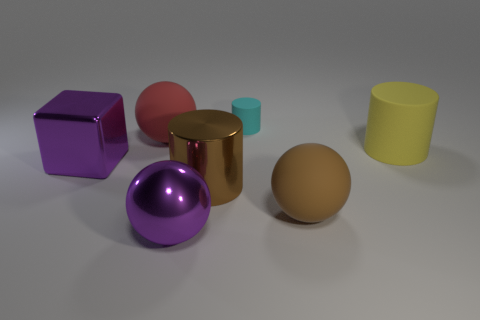Add 3 big yellow matte objects. How many objects exist? 10 Subtract all big shiny cylinders. How many cylinders are left? 2 Subtract 1 cylinders. How many cylinders are left? 2 Subtract all balls. How many objects are left? 4 Add 1 brown matte things. How many brown matte things are left? 2 Add 2 yellow things. How many yellow things exist? 3 Subtract 0 cyan cubes. How many objects are left? 7 Subtract all blue balls. Subtract all cyan cylinders. How many balls are left? 3 Subtract all tiny purple metallic cylinders. Subtract all big brown cylinders. How many objects are left? 6 